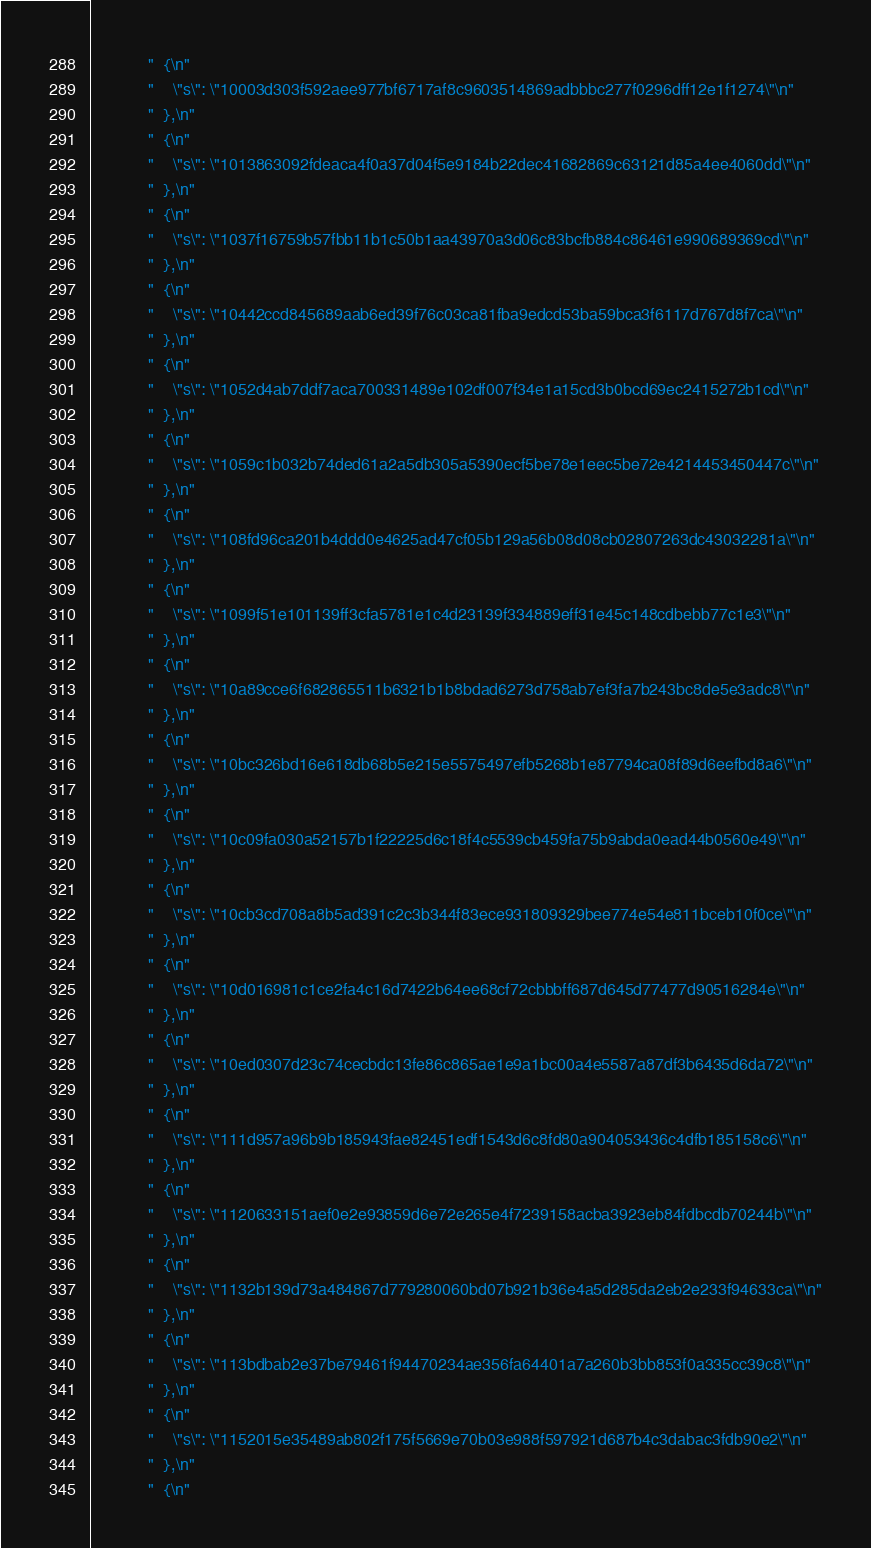<code> <loc_0><loc_0><loc_500><loc_500><_C_>            "  {\n"
            "    \"s\": \"10003d303f592aee977bf6717af8c9603514869adbbbc277f0296dff12e1f1274\"\n"
            "  },\n"
            "  {\n"
            "    \"s\": \"1013863092fdeaca4f0a37d04f5e9184b22dec41682869c63121d85a4ee4060dd\"\n"
            "  },\n"
            "  {\n"
            "    \"s\": \"1037f16759b57fbb11b1c50b1aa43970a3d06c83bcfb884c86461e990689369cd\"\n"
            "  },\n"
            "  {\n"
            "    \"s\": \"10442ccd845689aab6ed39f76c03ca81fba9edcd53ba59bca3f6117d767d8f7ca\"\n"
            "  },\n"
            "  {\n"
            "    \"s\": \"1052d4ab7ddf7aca700331489e102df007f34e1a15cd3b0bcd69ec2415272b1cd\"\n"
            "  },\n"
            "  {\n"
            "    \"s\": \"1059c1b032b74ded61a2a5db305a5390ecf5be78e1eec5be72e4214453450447c\"\n"
            "  },\n"
            "  {\n"
            "    \"s\": \"108fd96ca201b4ddd0e4625ad47cf05b129a56b08d08cb02807263dc43032281a\"\n"
            "  },\n"
            "  {\n"
            "    \"s\": \"1099f51e101139ff3cfa5781e1c4d23139f334889eff31e45c148cdbebb77c1e3\"\n"
            "  },\n"
            "  {\n"
            "    \"s\": \"10a89cce6f682865511b6321b1b8bdad6273d758ab7ef3fa7b243bc8de5e3adc8\"\n"
            "  },\n"
            "  {\n"
            "    \"s\": \"10bc326bd16e618db68b5e215e5575497efb5268b1e87794ca08f89d6eefbd8a6\"\n"
            "  },\n"
            "  {\n"
            "    \"s\": \"10c09fa030a52157b1f22225d6c18f4c5539cb459fa75b9abda0ead44b0560e49\"\n"
            "  },\n"
            "  {\n"
            "    \"s\": \"10cb3cd708a8b5ad391c2c3b344f83ece931809329bee774e54e811bceb10f0ce\"\n"
            "  },\n"
            "  {\n"
            "    \"s\": \"10d016981c1ce2fa4c16d7422b64ee68cf72cbbbff687d645d77477d90516284e\"\n"
            "  },\n"
            "  {\n"
            "    \"s\": \"10ed0307d23c74cecbdc13fe86c865ae1e9a1bc00a4e5587a87df3b6435d6da72\"\n"
            "  },\n"
            "  {\n"
            "    \"s\": \"111d957a96b9b185943fae82451edf1543d6c8fd80a904053436c4dfb185158c6\"\n"
            "  },\n"
            "  {\n"
            "    \"s\": \"1120633151aef0e2e93859d6e72e265e4f7239158acba3923eb84fdbcdb70244b\"\n"
            "  },\n"
            "  {\n"
            "    \"s\": \"1132b139d73a484867d779280060bd07b921b36e4a5d285da2eb2e233f94633ca\"\n"
            "  },\n"
            "  {\n"
            "    \"s\": \"113bdbab2e37be79461f94470234ae356fa64401a7a260b3bb853f0a335cc39c8\"\n"
            "  },\n"
            "  {\n"
            "    \"s\": \"1152015e35489ab802f175f5669e70b03e988f597921d687b4c3dabac3fdb90e2\"\n"
            "  },\n"
            "  {\n"</code> 